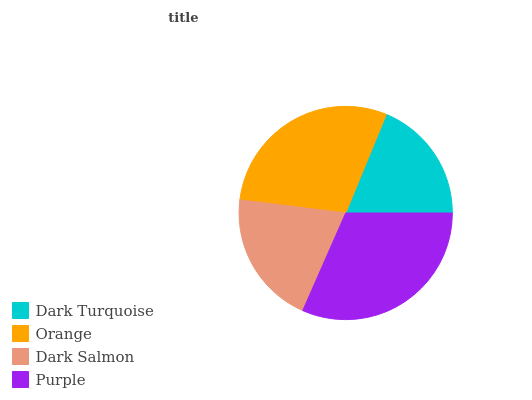Is Dark Turquoise the minimum?
Answer yes or no. Yes. Is Purple the maximum?
Answer yes or no. Yes. Is Orange the minimum?
Answer yes or no. No. Is Orange the maximum?
Answer yes or no. No. Is Orange greater than Dark Turquoise?
Answer yes or no. Yes. Is Dark Turquoise less than Orange?
Answer yes or no. Yes. Is Dark Turquoise greater than Orange?
Answer yes or no. No. Is Orange less than Dark Turquoise?
Answer yes or no. No. Is Orange the high median?
Answer yes or no. Yes. Is Dark Salmon the low median?
Answer yes or no. Yes. Is Dark Turquoise the high median?
Answer yes or no. No. Is Purple the low median?
Answer yes or no. No. 